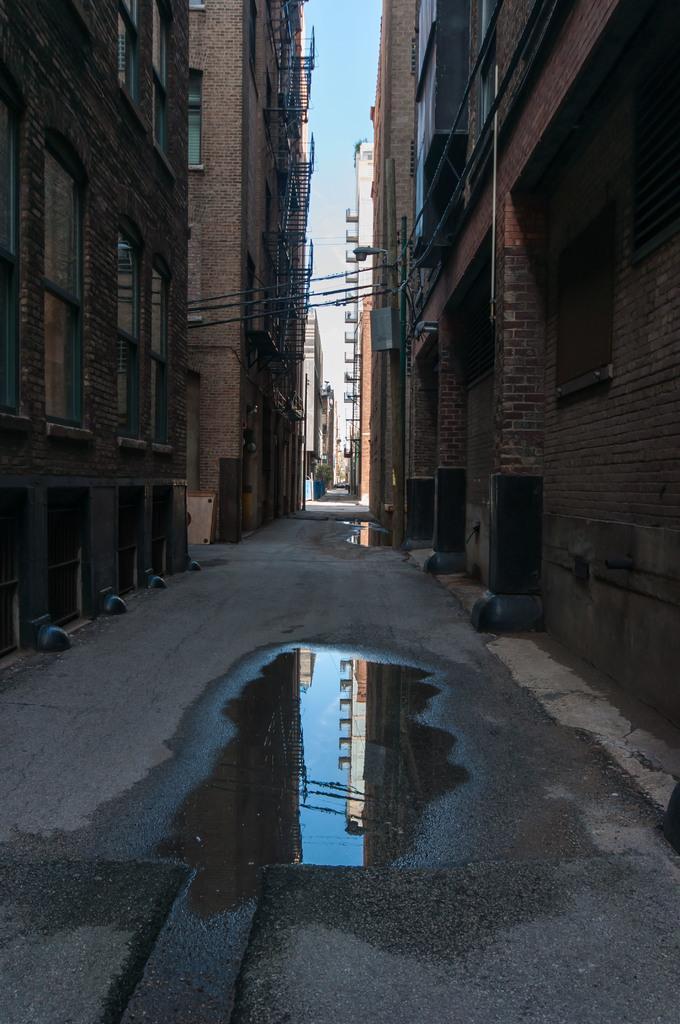Please provide a concise description of this image. There is water on the road. On both sides of this road, there are buildings which are having windows. In the background, there are buildings and there are clouds in the blue sky. 